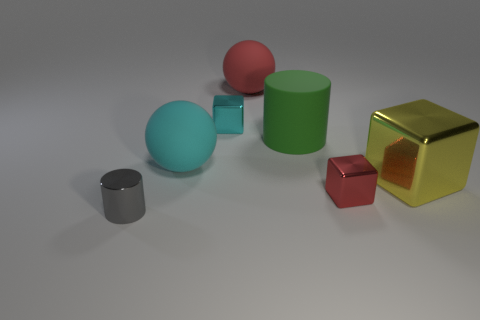What is the shape of the red object behind the cylinder behind the large yellow shiny thing?
Offer a terse response. Sphere. Are there any big green rubber cylinders that are in front of the small metallic object that is on the left side of the small shiny object behind the small red cube?
Offer a terse response. No. What color is the cylinder that is the same size as the cyan rubber object?
Your answer should be very brief. Green. What shape is the tiny object that is both left of the red sphere and in front of the tiny cyan metal thing?
Your answer should be compact. Cylinder. How big is the green object to the right of the big rubber ball on the left side of the big red rubber object?
Your answer should be very brief. Large. How many small metallic blocks have the same color as the large metal object?
Offer a very short reply. 0. How many other things are the same size as the gray metallic cylinder?
Keep it short and to the point. 2. There is a rubber thing that is both in front of the large red thing and to the right of the big cyan rubber sphere; what size is it?
Make the answer very short. Large. How many big green things are the same shape as the big red object?
Your answer should be compact. 0. What is the big cyan thing made of?
Offer a terse response. Rubber. 